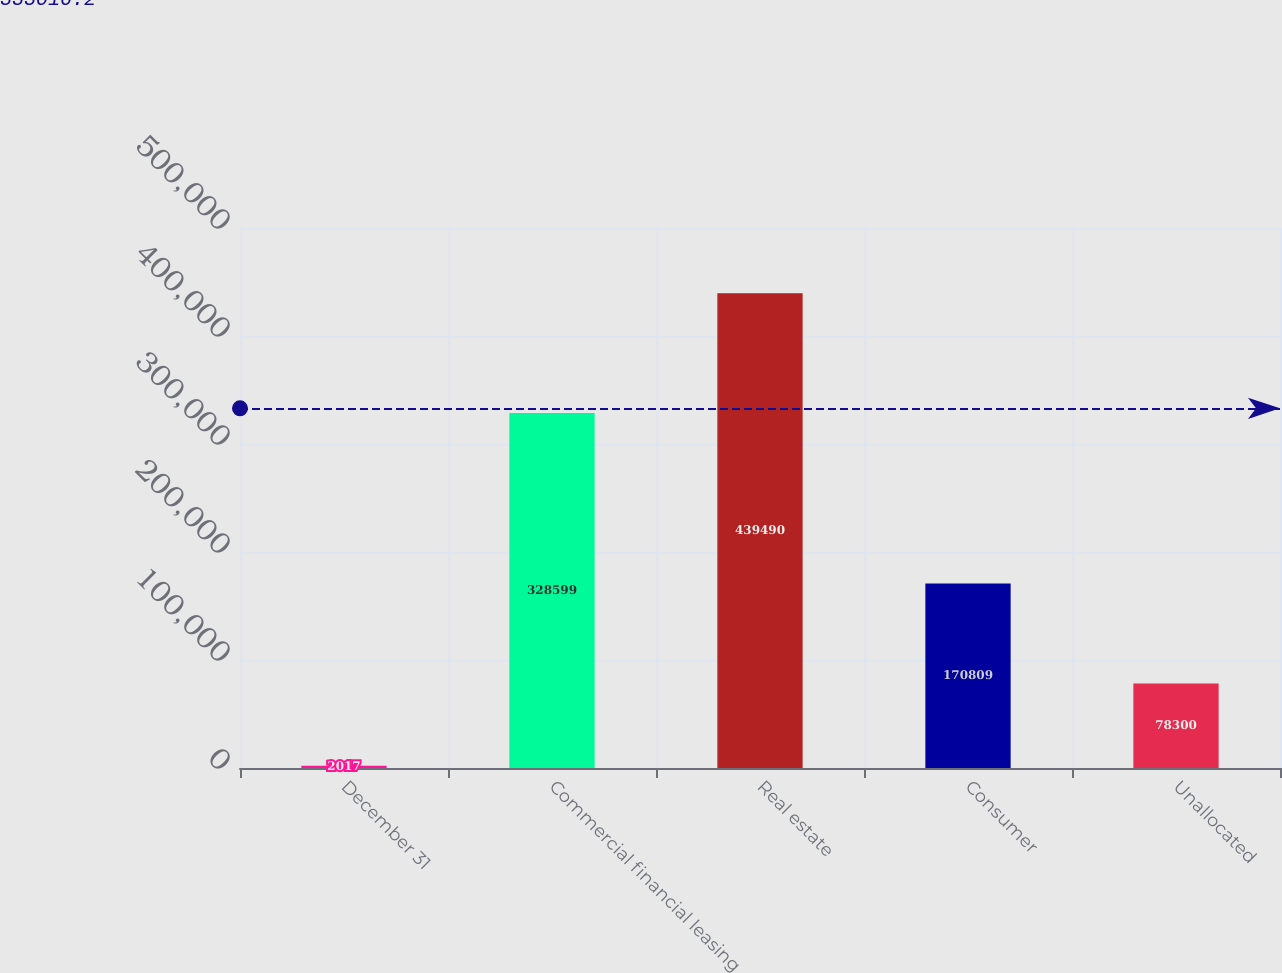Convert chart to OTSL. <chart><loc_0><loc_0><loc_500><loc_500><bar_chart><fcel>December 31<fcel>Commercial financial leasing<fcel>Real estate<fcel>Consumer<fcel>Unallocated<nl><fcel>2017<fcel>328599<fcel>439490<fcel>170809<fcel>78300<nl></chart> 